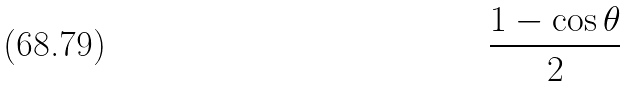Convert formula to latex. <formula><loc_0><loc_0><loc_500><loc_500>\frac { 1 - \cos \theta } { 2 }</formula> 